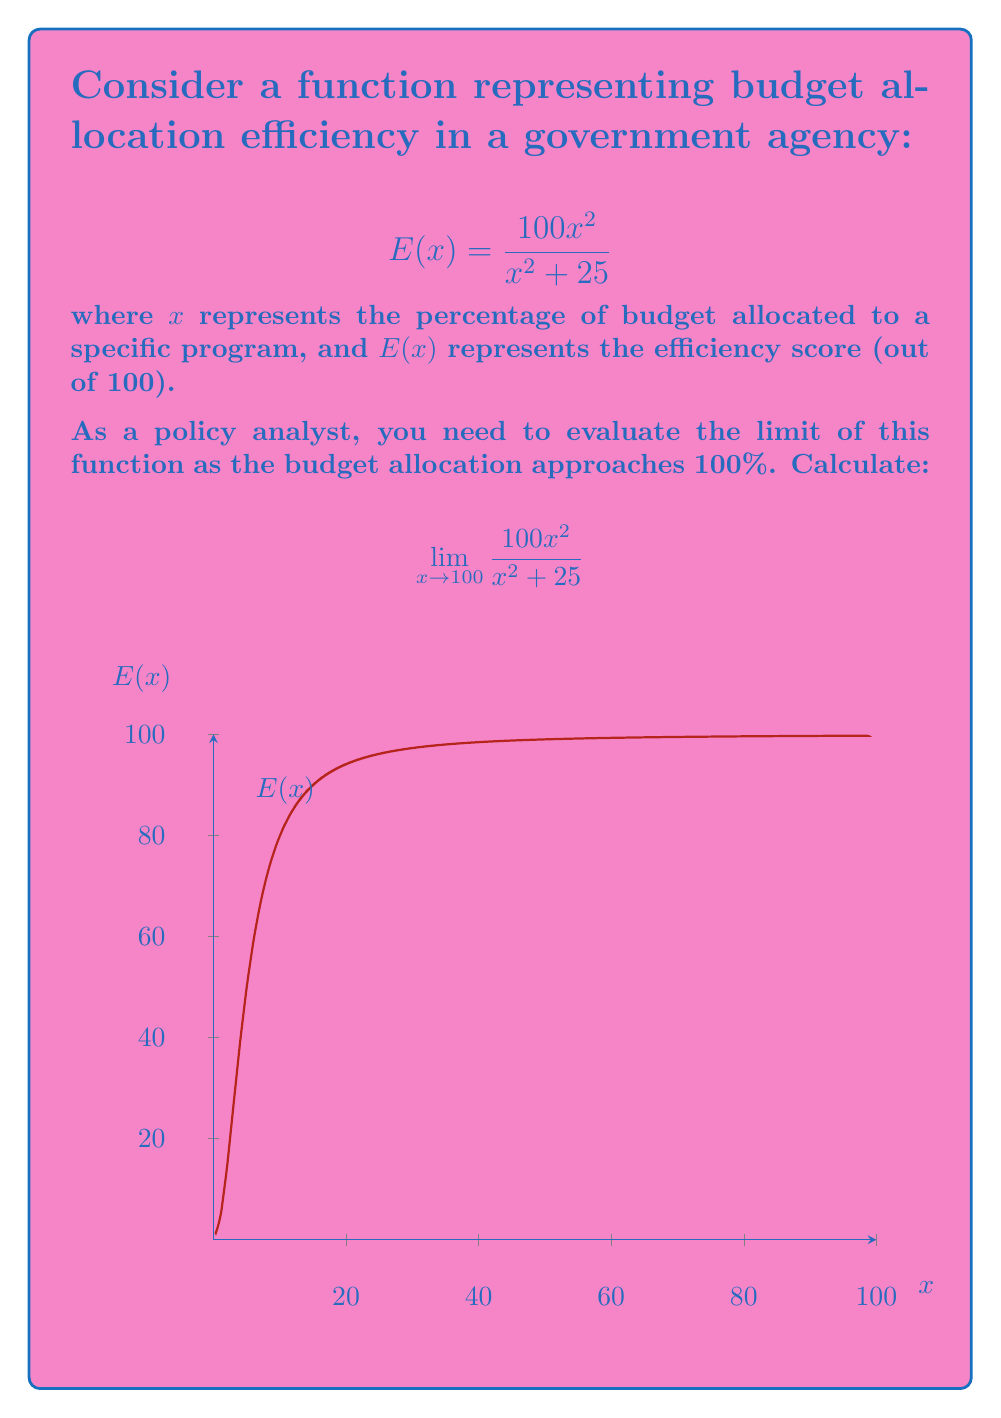Give your solution to this math problem. To evaluate this limit, we'll follow these steps:

1) First, let's substitute $x = 100$ into the function:
   $$\lim_{x \to 100} \frac{100x^2}{x^2 + 25} = \frac{100(100)^2}{100^2 + 25}$$

2) Simplify:
   $$= \frac{100(10000)}{10000 + 25} = \frac{1000000}{10025}$$

3) Divide:
   $$= 99.75062344139650$$

4) Round to two decimal places for practical interpretation:
   $$\approx 99.75$$

This result indicates that as the budget allocation approaches 100%, the efficiency score approaches 99.75 out of 100, suggesting a very high level of efficiency at maximum budget allocation.

From a policy perspective, this implies that increasing budget allocation towards 100% results in diminishing returns in efficiency, with a theoretical maximum slightly below perfect efficiency.
Answer: $99.75$ (rounded to two decimal places) 